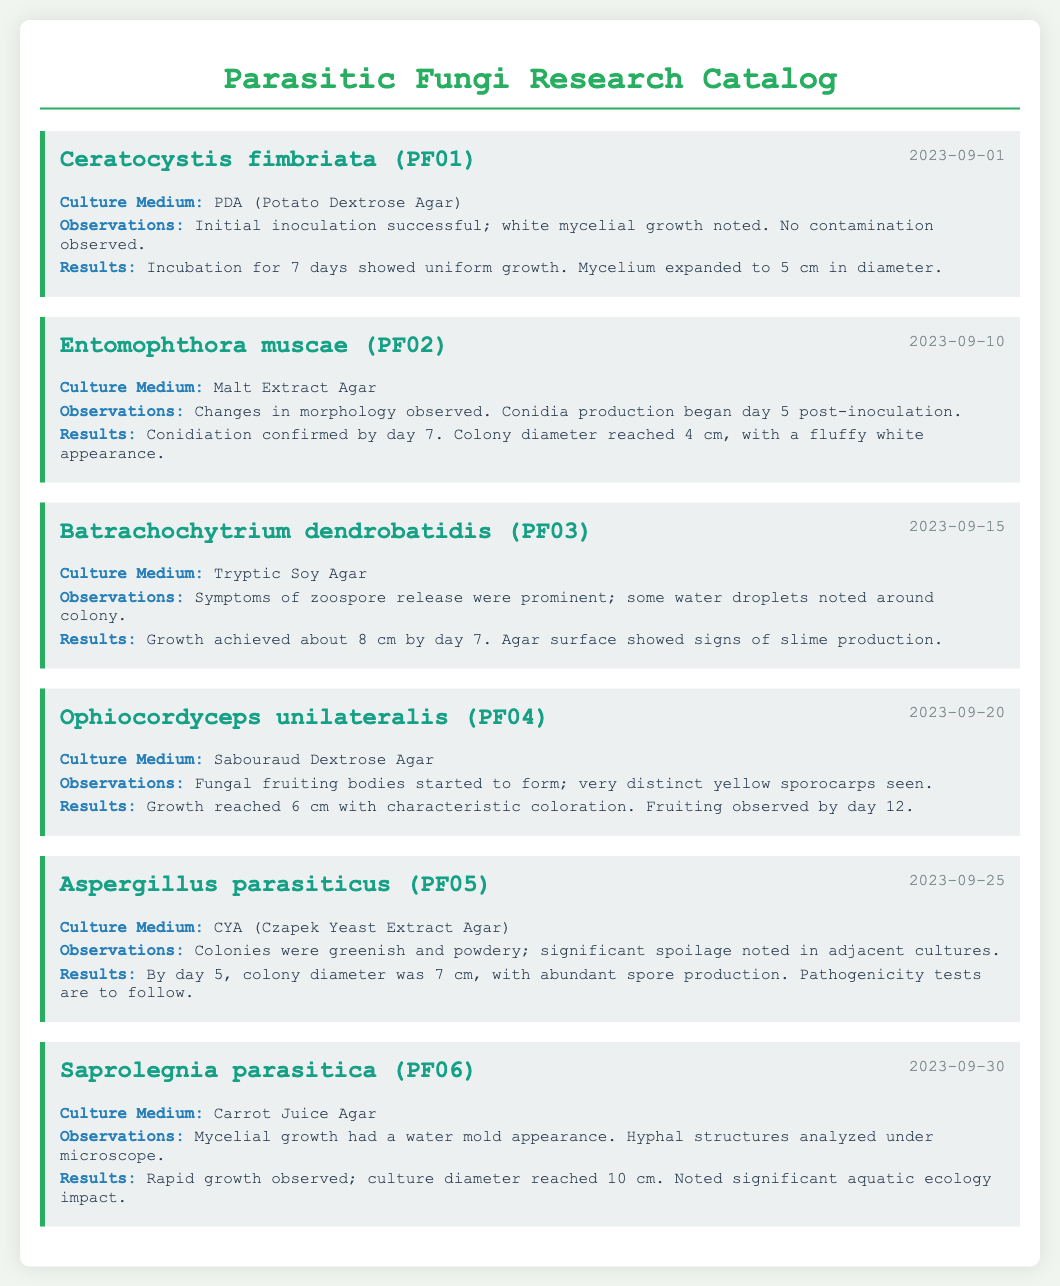What is the date of the first entry? The first entry in the catalog is dated September 1, 2023.
Answer: September 1, 2023 Which culture medium was used for Cereatocystis fimbriata? The culture medium for Cereatocystis fimbriata (PF01) is PDA (Potato Dextrose Agar).
Answer: PDA (Potato Dextrose Agar) How many centimeters did the mycelium of Aspergillus parasiticus grow to by day 5? By day 5, the colony diameter of Aspergillus parasiticus (PF05) was 7 cm.
Answer: 7 cm What type of fungi did the September 20 entry focus on? The entry dated September 20 is focused on Ophiocordyceps unilateralis.
Answer: Ophiocordyceps unilateralis Which fungus showed signs of slime production? Batrachochytrium dendrobatidis (PF03) showed signs of slime production.
Answer: Batrachochytrium dendrobatidis (PF03) What was the significant observation for Saprolegnia parasitica? The significant observation for Saprolegnia parasitica was the water mold appearance of mycelial growth.
Answer: water mold appearance What day was conidiation confirmed for Entomophthora muscae? Conidiation was confirmed by day 7 for Entomophthora muscae (PF02).
Answer: day 7 Which fungus had a fluffy white appearance by day 7? The fungus with a fluffy white appearance by day 7 is Entomophthora muscae (PF02).
Answer: Entomophthora muscae (PF02) 